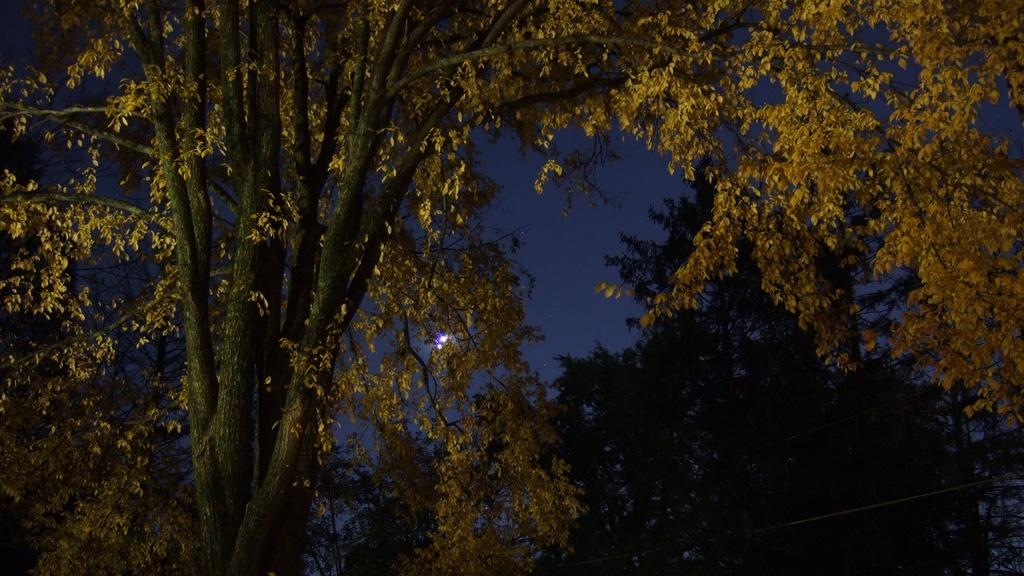What type of vegetation can be seen in the image? There are trees in the image. What part of the natural environment is visible in the image? The sky is visible in the background of the image. What type of basin is visible in the image? There is no basin present in the image. What answer can be found in the image? The image does not contain any answers, as it is a visual representation and not a source of information or knowledge. 